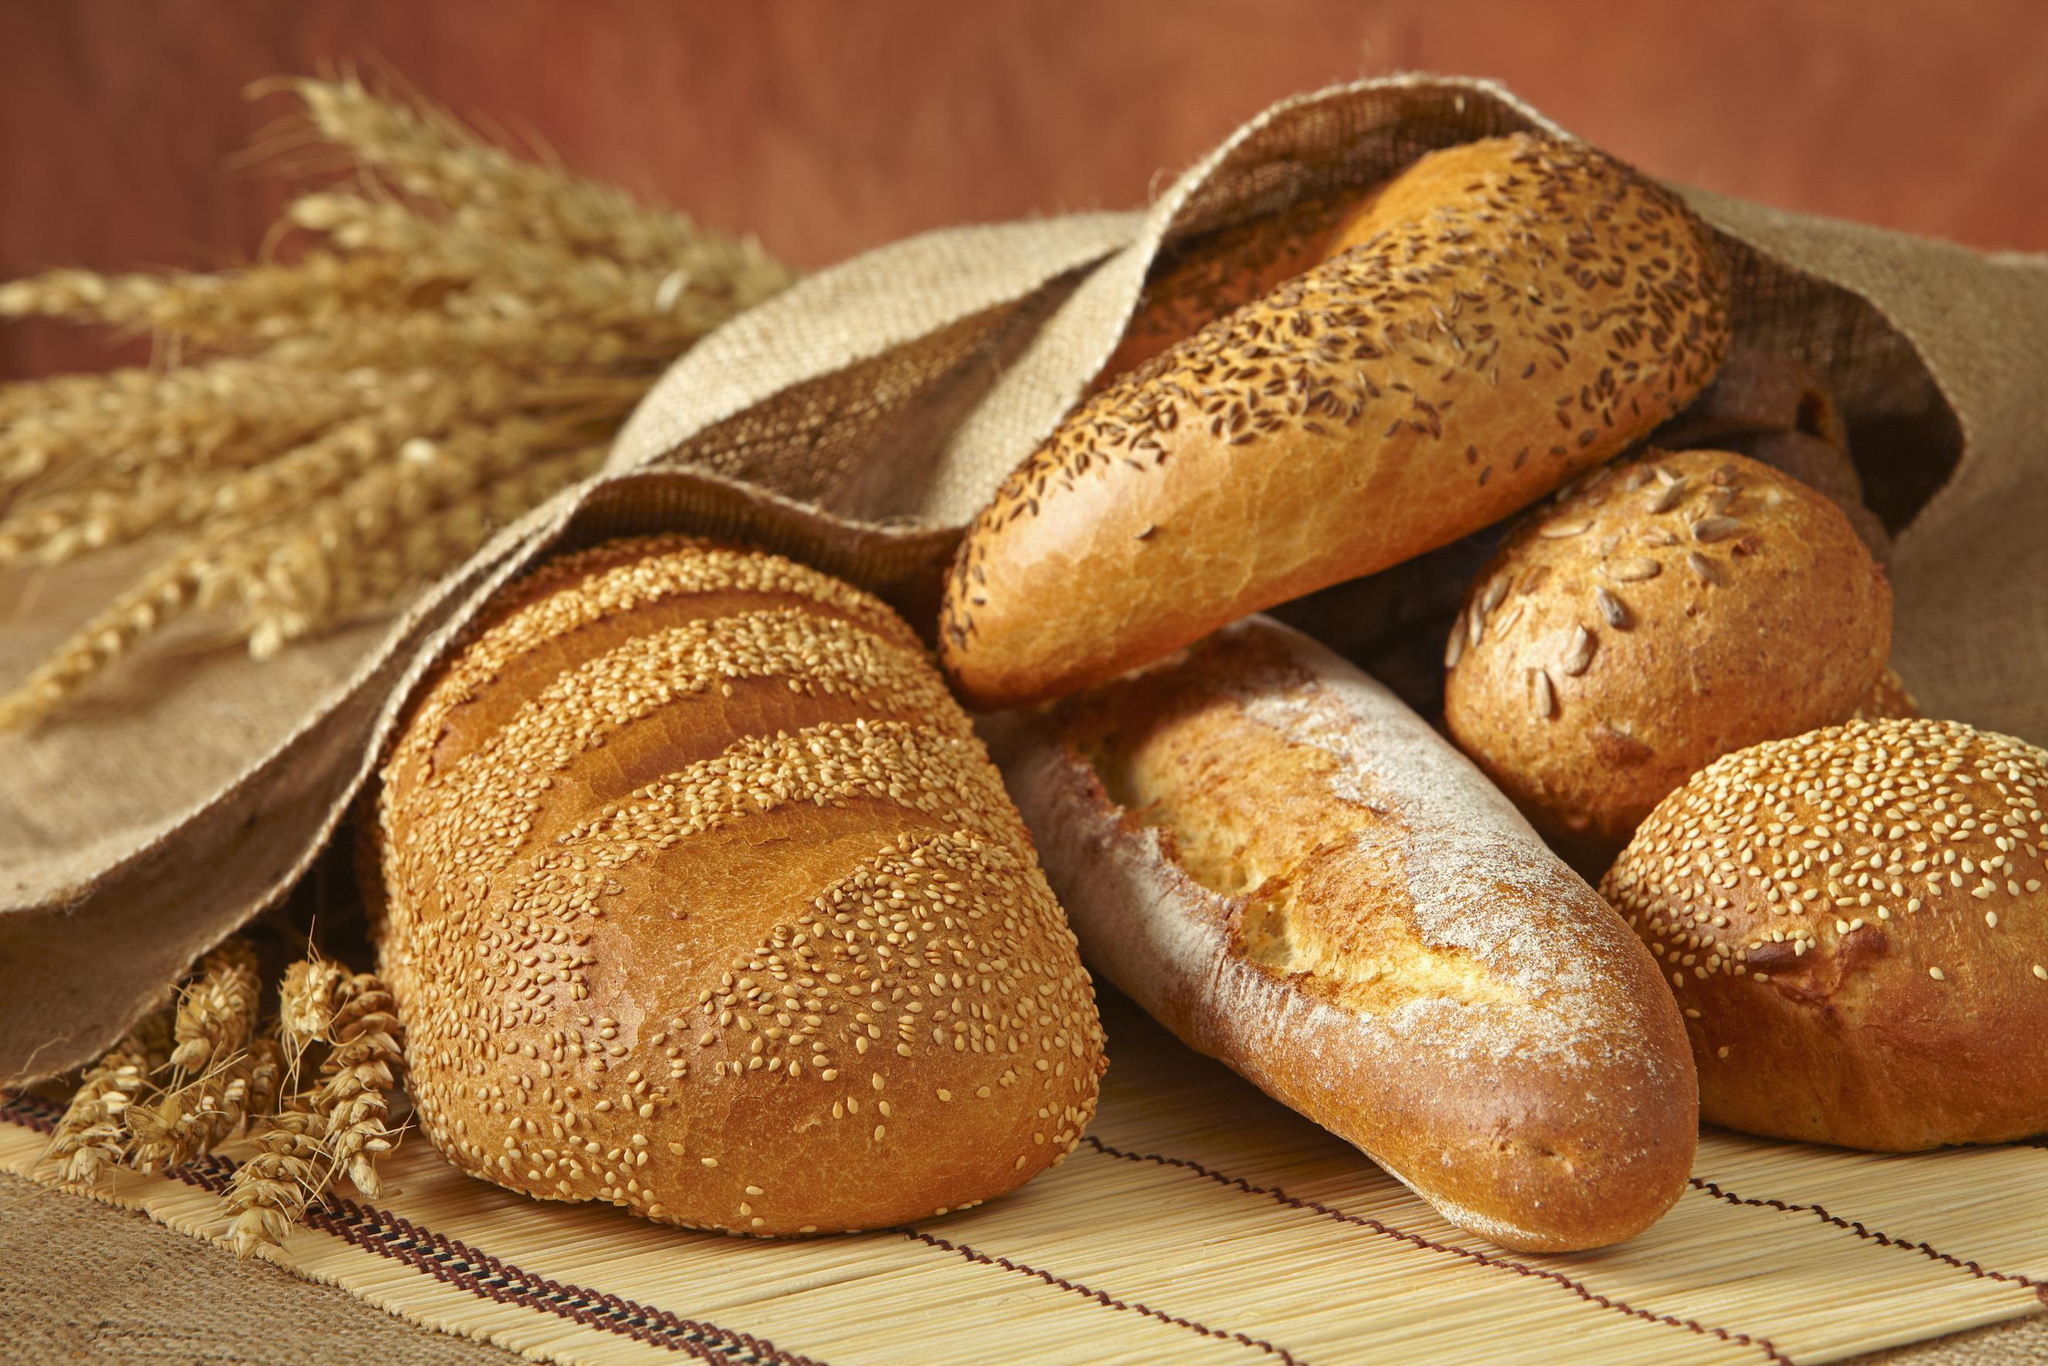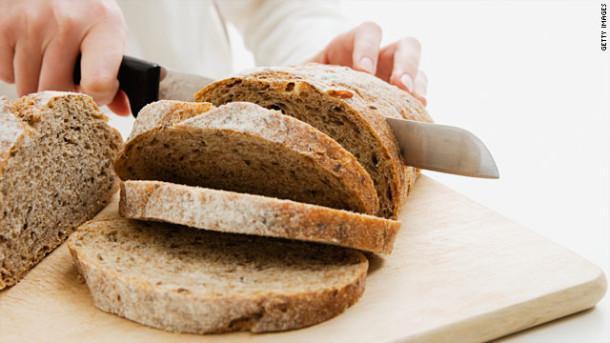The first image is the image on the left, the second image is the image on the right. Given the left and right images, does the statement "The bread in the image on the left has already been sliced." hold true? Answer yes or no. No. The first image is the image on the left, the second image is the image on the right. Given the left and right images, does the statement "The left image includes at least two slices of bread overlapping in front of a cut loaf, and the right image shows one flat-bottomed round bread leaning against one that is sitting flat." hold true? Answer yes or no. No. 